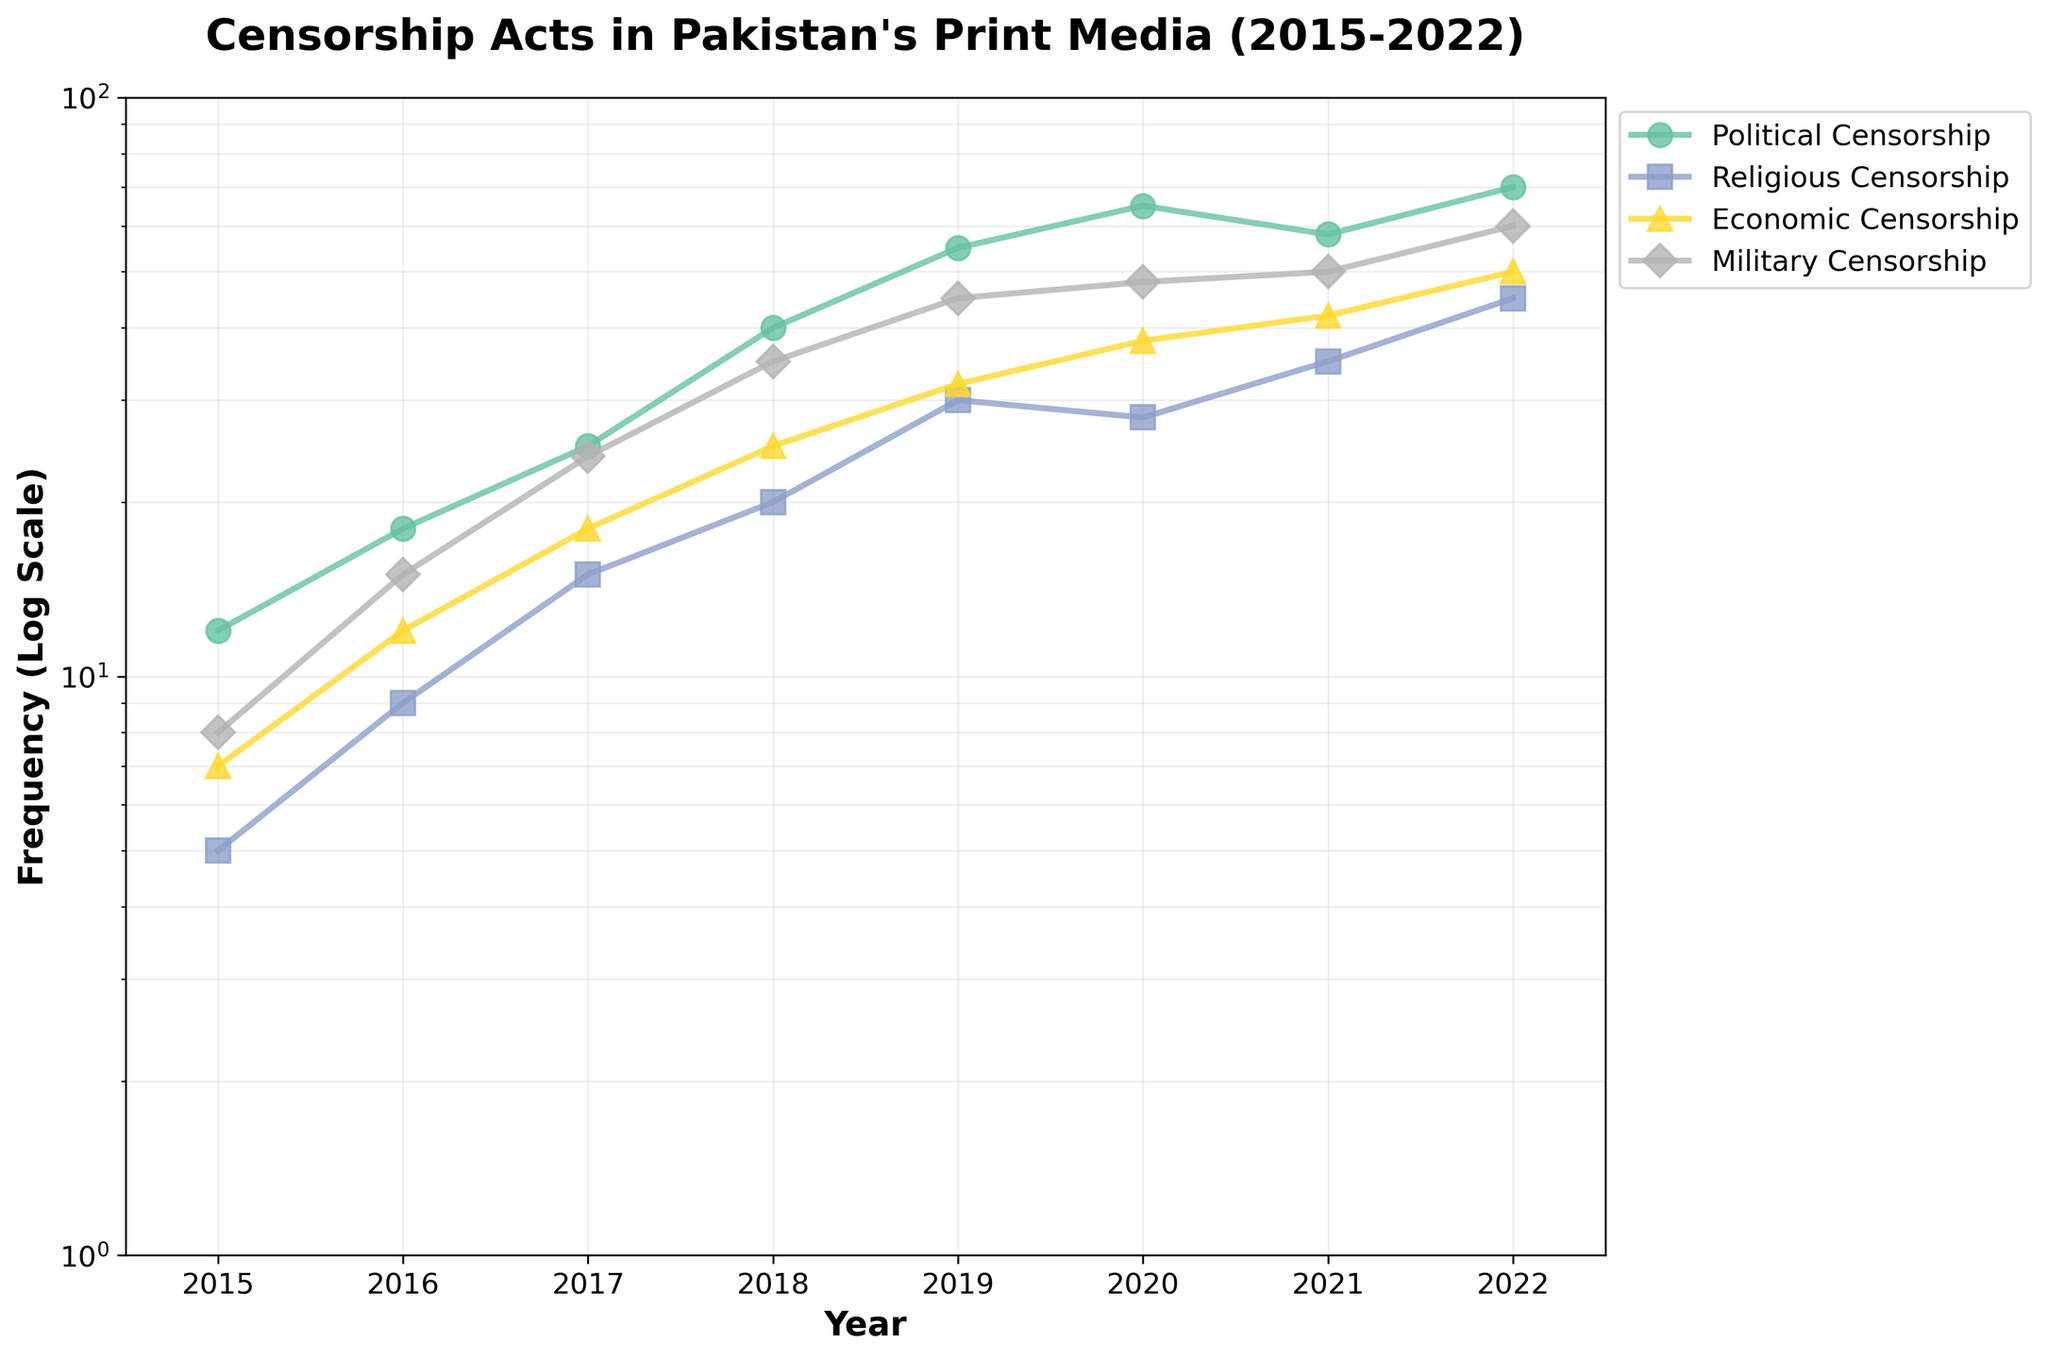Which type of censorship acts had the highest frequency in 2022? By looking at the endpoints of the plots for 2022, Political Censorship had the highest frequency.
Answer: Political Censorship How did Religious Censorship frequency change from 2015 to 2022? The frequency of Religious Censorship increased from 5 in 2015 to 45 in 2022.
Answer: Increased by 40 Which years show the highest spike in Political Censorship frequency? By observing the plot, significant spikes in Political Censorship occurred between 2017-2018 and 2018-2019.
Answer: 2017-2018 and 2018-2019 What's the total combined frequency of Economic and Military Censorship in 2020? The frequency of Economic Censorship in 2020 is 38. The frequency of Military Censorship in 2020 is 48. Summing these gives 38 + 48 = 86.
Answer: 86 In which year did Military Censorship surpass the 40 mark, and what was its frequency? Military Censorship surpassed the 40 mark in 2019 with a frequency of 45.
Answer: 2019, 45 How does the growth rate of Economic Censorship compare to that of Political Censorship from 2019 to 2022? Economic Censorship grew from 32 in 2019 to 50 in 2022; Political Censorship grew from 55 in 2019 to 70 in 2022. Economic Censorship increased by 18 (50 - 32), while Political Censorship increased by 15 (70 - 55). Economic Censorship had a slightly higher growth rate.
Answer: Economic Censorship had a slightly higher growth rate What's the median frequency of Religious Censorship acts from 2015 to 2022? The frequencies of Religious Censorship acts from 2015 to 2022 are sorted as [5, 9, 15, 20, 28, 30, 35, 45]. The median is the average of the 4th and 5th values, which is (20+28)/2 = 24.
Answer: 24 Which censorship type had the most consistent frequency trend over the years? By observing the plots, Economic Censorship shows a more consistent upward trend with fewer fluctuations compared to the others.
Answer: Economic Censorship How many different types of censorship acts are tracked in the figure? The plot shows four different types of censorship acts: Political, Religious, Economic, Military.
Answer: Four 